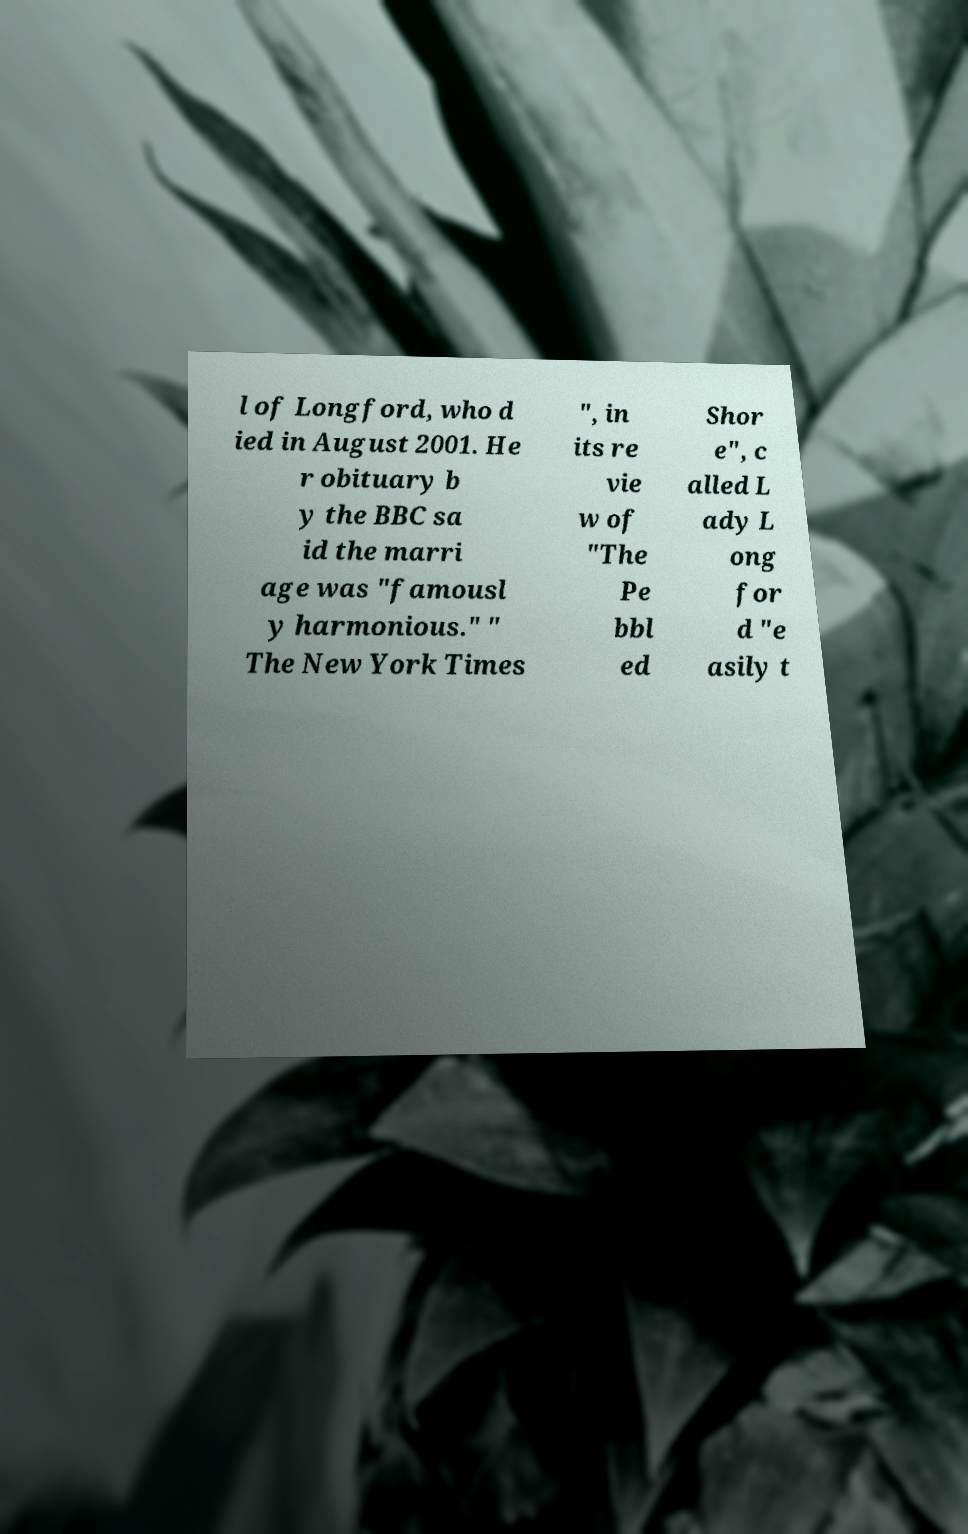I need the written content from this picture converted into text. Can you do that? l of Longford, who d ied in August 2001. He r obituary b y the BBC sa id the marri age was "famousl y harmonious." " The New York Times ", in its re vie w of "The Pe bbl ed Shor e", c alled L ady L ong for d "e asily t 